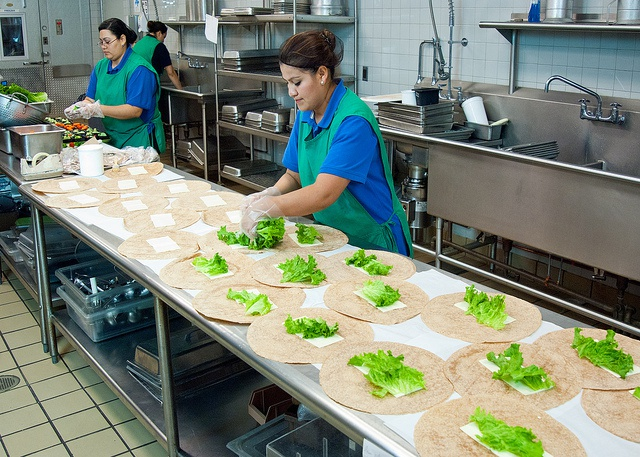Describe the objects in this image and their specific colors. I can see people in darkgray, teal, blue, black, and turquoise tones, sink in darkgray, gray, black, and lightgray tones, people in darkgray, black, blue, and teal tones, bowl in darkgray, gray, and black tones, and people in darkgray, black, teal, gray, and maroon tones in this image. 